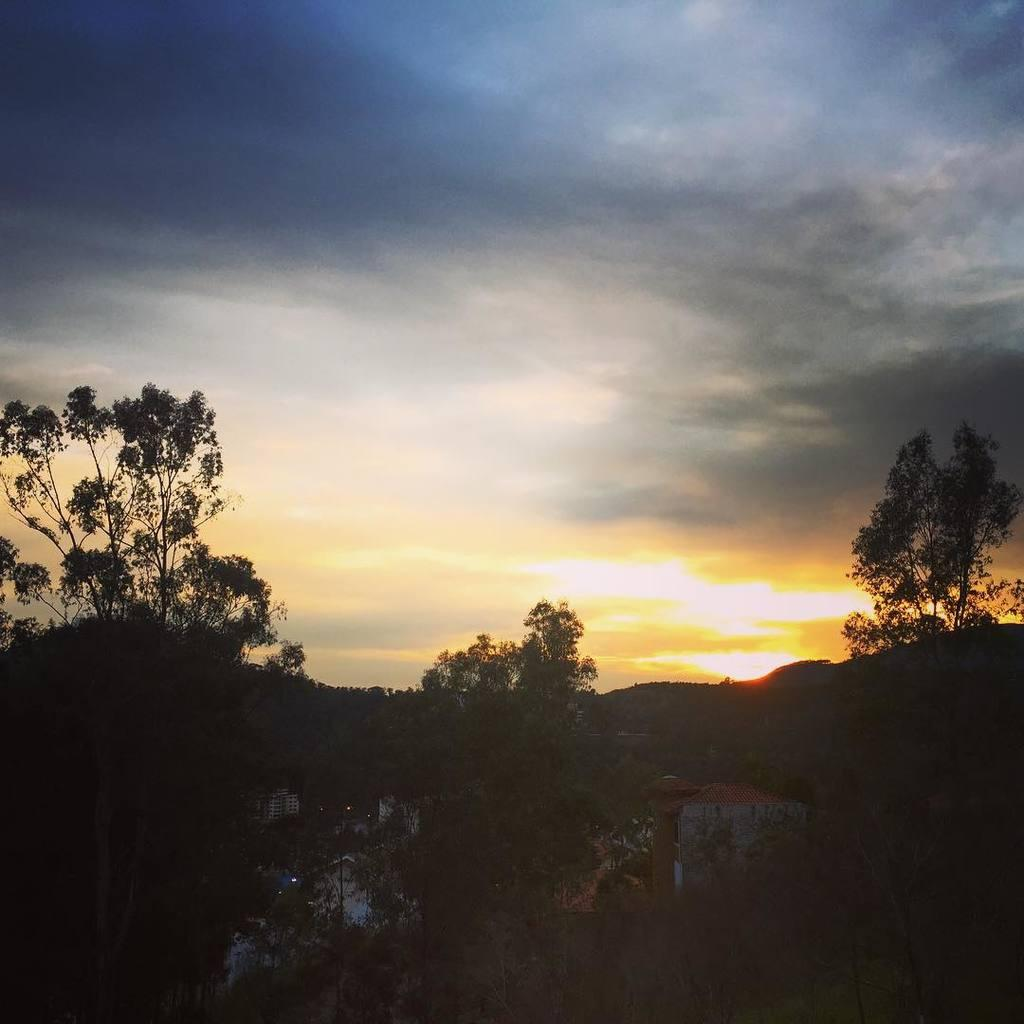What type of structures can be seen in the image? There are buildings in the image. What other natural elements are present in the image? There are trees in the image. What part of the natural environment is visible in the image? The sky is visible in the image. How many coughs can be heard in the image? There are no audible sounds, such as coughs, present in the image. 